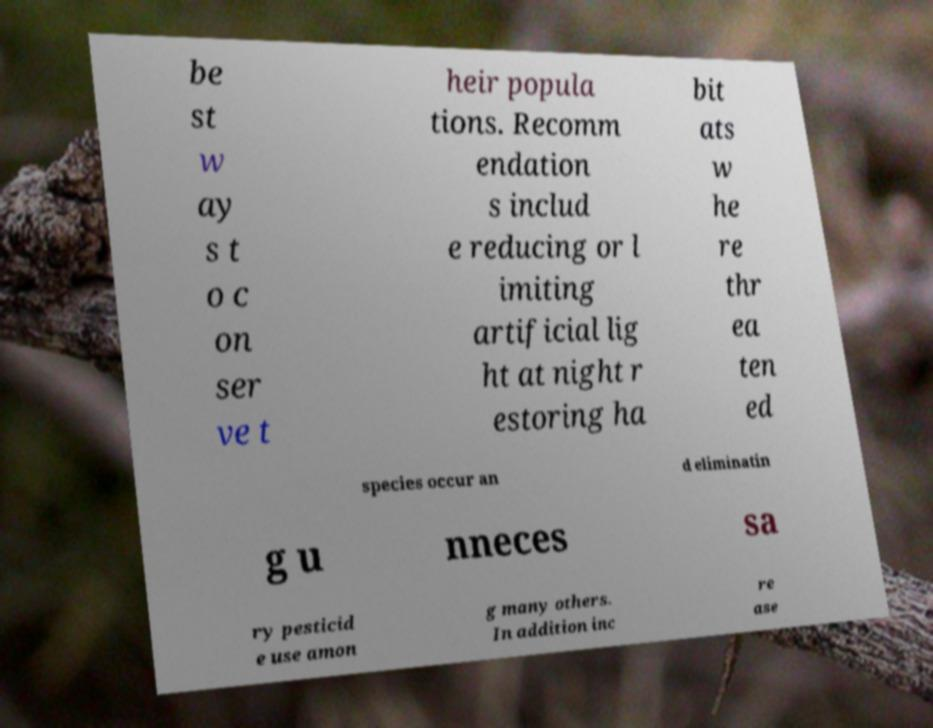For documentation purposes, I need the text within this image transcribed. Could you provide that? be st w ay s t o c on ser ve t heir popula tions. Recomm endation s includ e reducing or l imiting artificial lig ht at night r estoring ha bit ats w he re thr ea ten ed species occur an d eliminatin g u nneces sa ry pesticid e use amon g many others. In addition inc re ase 